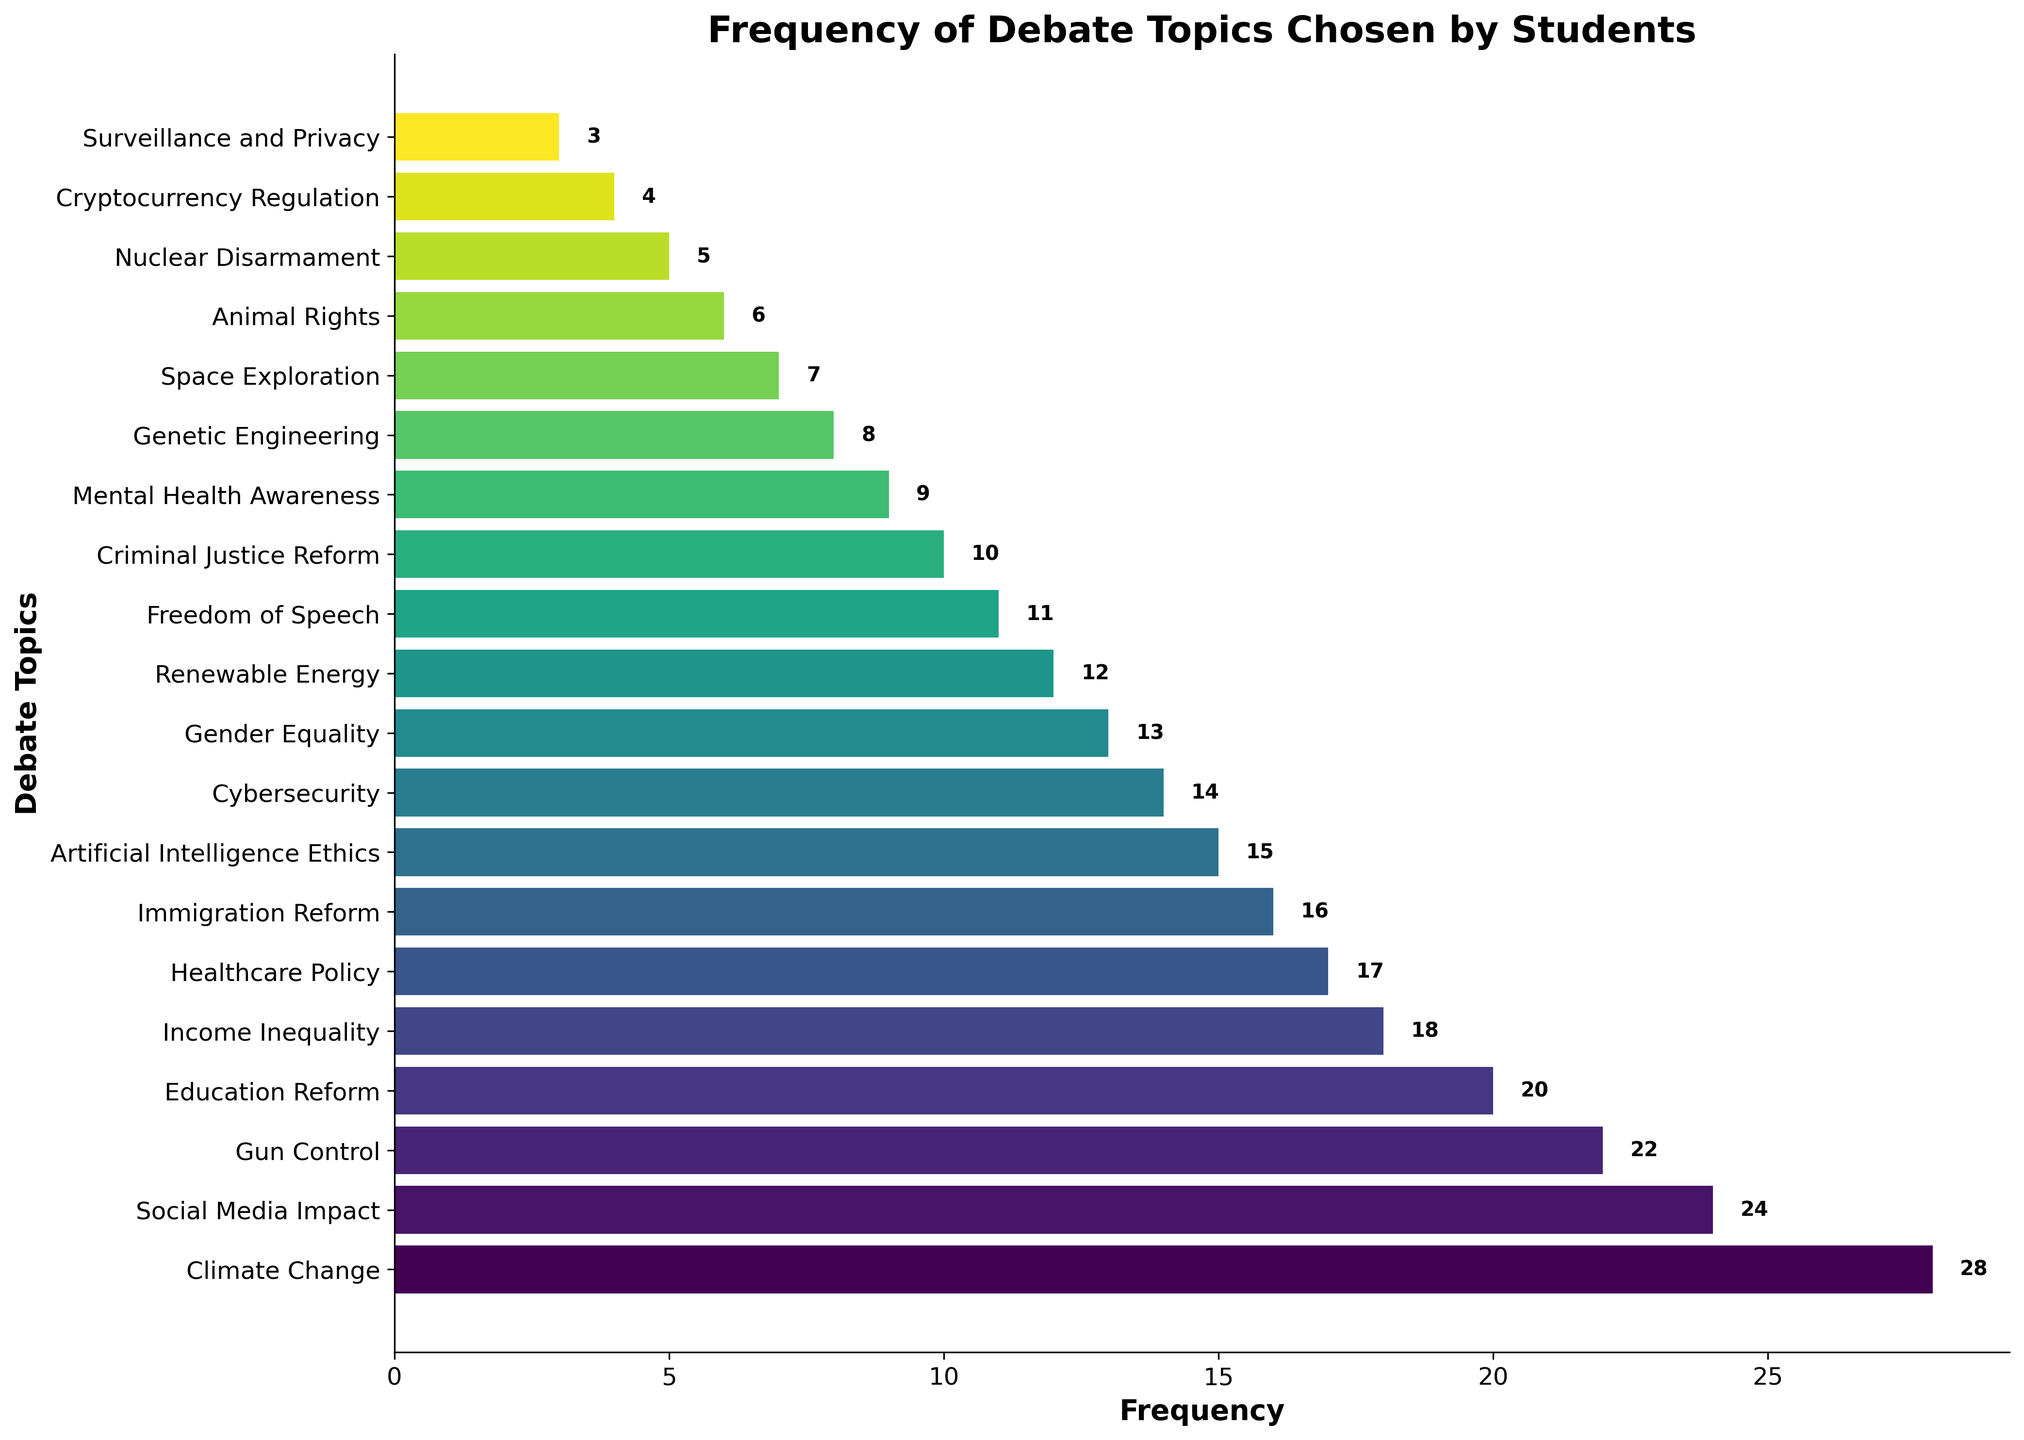Which topic is chosen most frequently? By observing the bar chart, the topic with the longest bar represents the most frequently chosen topic. In this case, it is "Climate Change" with 28 mentions.
Answer: Climate Change Which topic is chosen least frequently, and how many times? The shortest bar on the chart indicates the least frequent topic. "Surveillance and Privacy" is chosen the least with only 3 mentions.
Answer: Surveillance and Privacy, 3 How many times more frequent is "Climate Change" compared to "Surveillance and Privacy"? The frequency of "Climate Change" is 28, and for "Surveillance and Privacy" it is 3. Subtracting the smaller from the larger gives 28 - 3 = 25.
Answer: 25 What is the total frequency of all topics combined? To find the total, sum the frequency of all the bars: \(28 + 24 + 22 + 20 + 18 + 17 + 16 + 15 + 14 + 13 + 12 + 11 + 10 + 9 + 8 + 7 + 6 + 5 + 4 + 3 = 243\).
Answer: 243 Which topics have frequencies greater than 20? By observing the length of the bars, topics with frequencies greater than 20 are identified: "Climate Change" (28), "Social Media Impact" (24), and "Gun Control" (22).
Answer: Climate Change, Social Media Impact, Gun Control How many topics have frequencies less than 10? Identify the bars that are shorter and have values less than 10; they are: "Mental Health Awareness", "Genetic Engineering", "Space Exploration", "Animal Rights", "Nuclear Disarmament", "Cryptocurrency Regulation", and "Surveillance and Privacy". This gives a total of 7 topics.
Answer: 7 What is the frequency difference between "Gender Equality" and "Cybersecurity"? "Gender Equality" has a frequency of 13, and "Cybersecurity" has a frequency of 14. The difference is calculated as \(14 - 13 = 1\).
Answer: 1 Which two topics have the closest frequencies, and what are their frequencies? By scanning the bars, "Gender Equality" (13) and "Cybersecurity" (14) appear to have the closest frequencies.
Answer: Gender Equality, Cybersecurity (13, 14) Combine the frequencies of "Renewable Energy" and "Freedom of Speech." What is the result? Adding the frequencies of "Renewable Energy" (12) and "Freedom of Speech" (11) gives \(12 + 11 = 23\).
Answer: 23 What is the average frequency of the top 5 most chosen topics? Top 5 topics are: Climate Change (28), Social Media Impact (24), Gun Control (22), Education Reform (20), and Income Inequality (18). Their average frequency is \((28 + 24 + 22 + 20 + 18) / 5 = 112 / 5\) which equals 22.4.
Answer: 22.4 